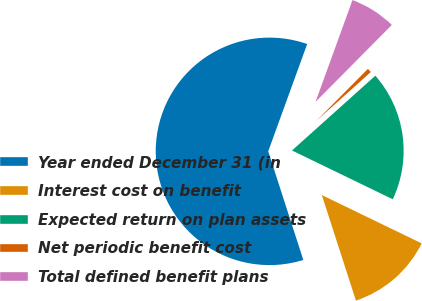<chart> <loc_0><loc_0><loc_500><loc_500><pie_chart><fcel>Year ended December 31 (in<fcel>Interest cost on benefit<fcel>Expected return on plan assets<fcel>Net periodic benefit cost<fcel>Total defined benefit plans<nl><fcel>60.51%<fcel>12.85%<fcel>18.81%<fcel>0.93%<fcel>6.89%<nl></chart> 